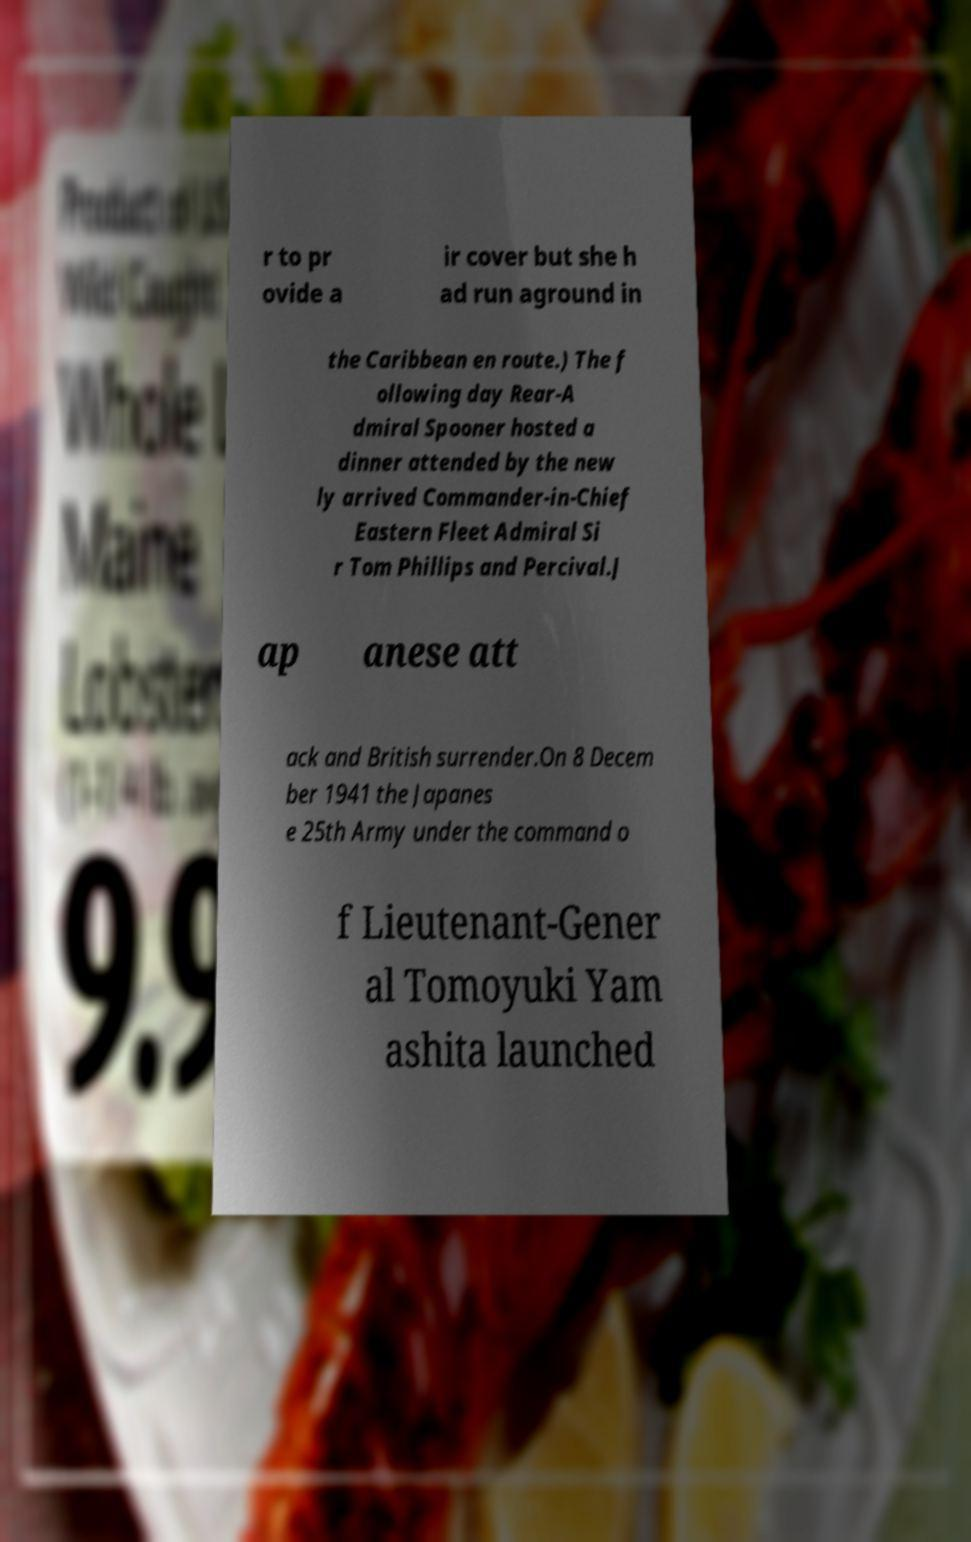For documentation purposes, I need the text within this image transcribed. Could you provide that? r to pr ovide a ir cover but she h ad run aground in the Caribbean en route.) The f ollowing day Rear-A dmiral Spooner hosted a dinner attended by the new ly arrived Commander-in-Chief Eastern Fleet Admiral Si r Tom Phillips and Percival.J ap anese att ack and British surrender.On 8 Decem ber 1941 the Japanes e 25th Army under the command o f Lieutenant-Gener al Tomoyuki Yam ashita launched 